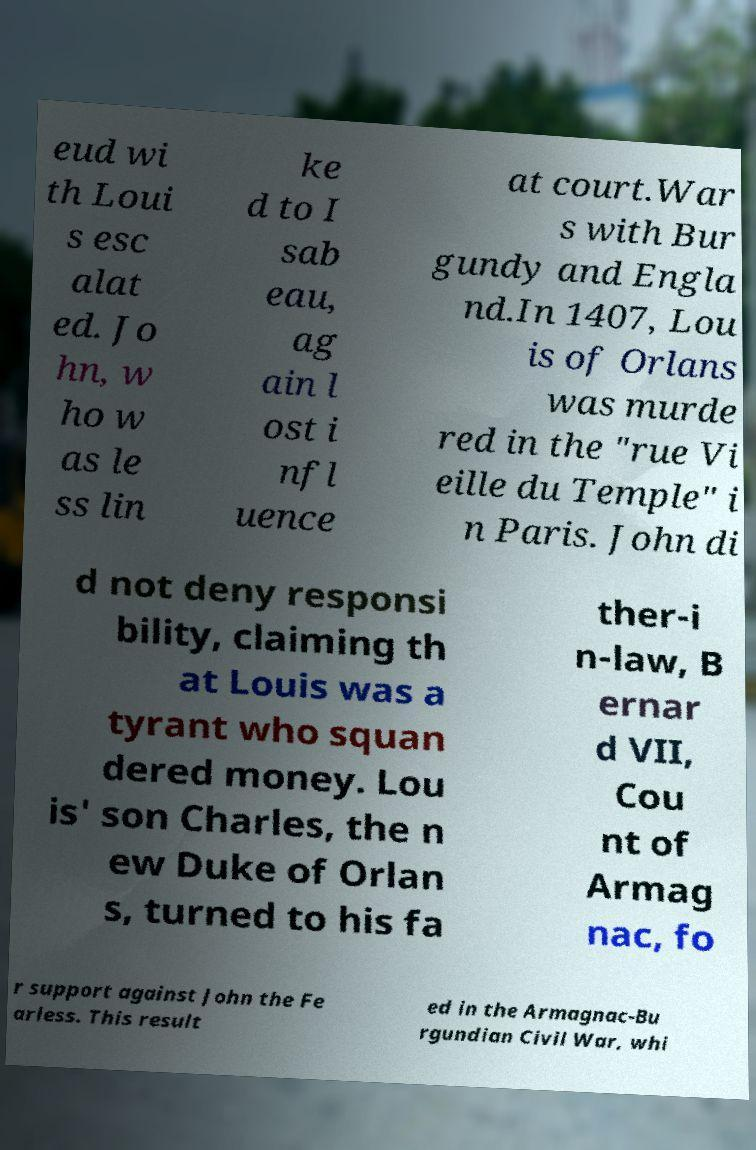I need the written content from this picture converted into text. Can you do that? eud wi th Loui s esc alat ed. Jo hn, w ho w as le ss lin ke d to I sab eau, ag ain l ost i nfl uence at court.War s with Bur gundy and Engla nd.In 1407, Lou is of Orlans was murde red in the "rue Vi eille du Temple" i n Paris. John di d not deny responsi bility, claiming th at Louis was a tyrant who squan dered money. Lou is' son Charles, the n ew Duke of Orlan s, turned to his fa ther-i n-law, B ernar d VII, Cou nt of Armag nac, fo r support against John the Fe arless. This result ed in the Armagnac-Bu rgundian Civil War, whi 